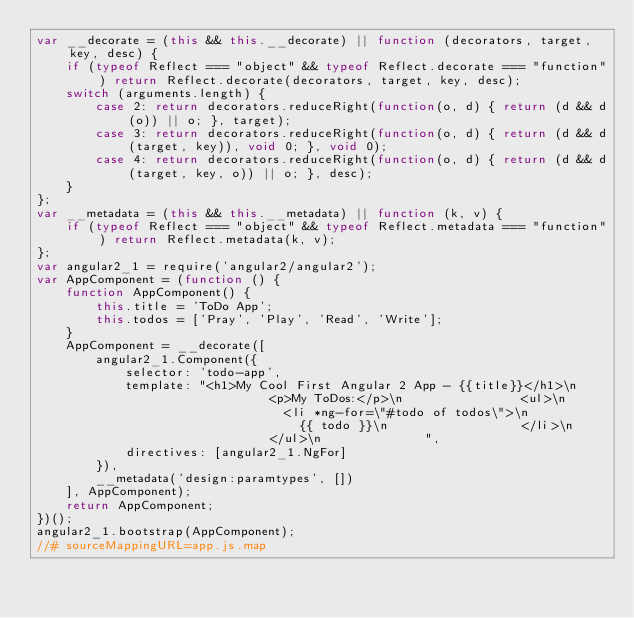<code> <loc_0><loc_0><loc_500><loc_500><_JavaScript_>var __decorate = (this && this.__decorate) || function (decorators, target, key, desc) {
    if (typeof Reflect === "object" && typeof Reflect.decorate === "function") return Reflect.decorate(decorators, target, key, desc);
    switch (arguments.length) {
        case 2: return decorators.reduceRight(function(o, d) { return (d && d(o)) || o; }, target);
        case 3: return decorators.reduceRight(function(o, d) { return (d && d(target, key)), void 0; }, void 0);
        case 4: return decorators.reduceRight(function(o, d) { return (d && d(target, key, o)) || o; }, desc);
    }
};
var __metadata = (this && this.__metadata) || function (k, v) {
    if (typeof Reflect === "object" && typeof Reflect.metadata === "function") return Reflect.metadata(k, v);
};
var angular2_1 = require('angular2/angular2');
var AppComponent = (function () {
    function AppComponent() {
        this.title = 'ToDo App';
        this.todos = ['Pray', 'Play', 'Read', 'Write'];
    }
    AppComponent = __decorate([
        angular2_1.Component({
            selector: 'todo-app',
            template: "<h1>My Cool First Angular 2 App - {{title}}</h1>\n                <p>My ToDos:</p>\n                <ul>\n                  <li *ng-for=\"#todo of todos\">\n                    {{ todo }}\n                  </li>\n                </ul>\n              ",
            directives: [angular2_1.NgFor]
        }), 
        __metadata('design:paramtypes', [])
    ], AppComponent);
    return AppComponent;
})();
angular2_1.bootstrap(AppComponent);
//# sourceMappingURL=app.js.map</code> 